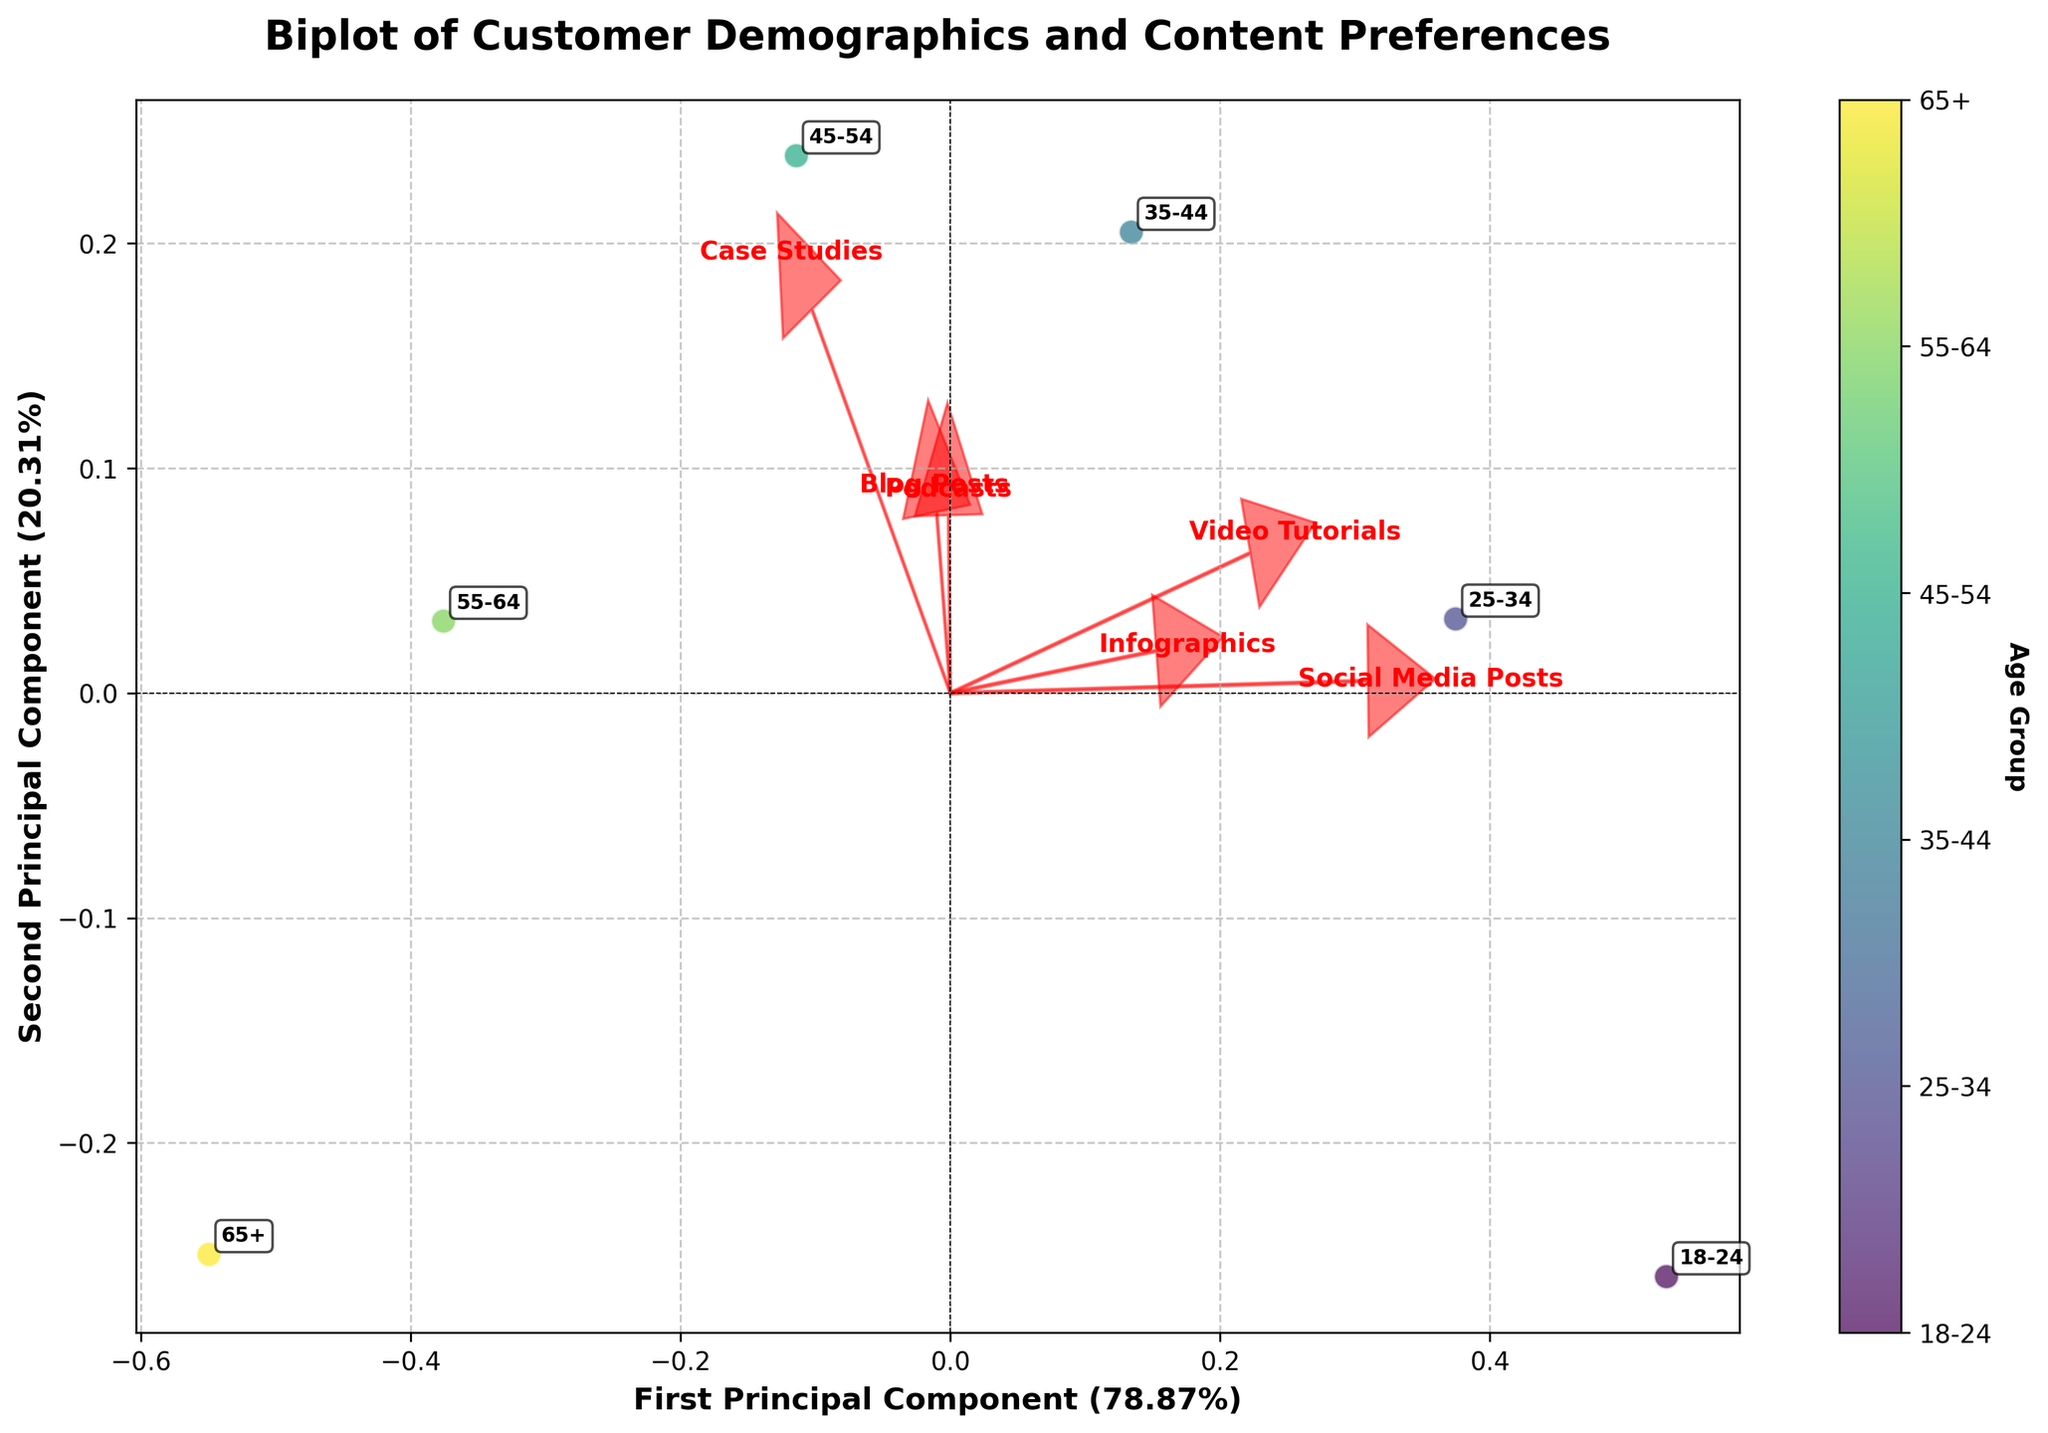How many age groups are represented in the biplot? The biplot shows the data points for each age group. By counting the number of different labels annotated next to the points, we can see there are six distinct age groups.
Answer: Six Which age group shows the highest preference for Video Tutorials? By looking at the length and direction of the arrow representing Video Tutorials and the closeness of the age group points to this arrow, we can infer that the 18-24 age group has the highest preference for Video Tutorials.
Answer: 18-24 What is the approximate variance explained by the first principal component? The x-axis label states "First Principal Component" and shows the variance explained as a percentage in parentheses. By reading this percentage, we find the value.
Answer: Approximately 51% Between 35-44 and 45-54 age groups, which age group shows a higher preference for Podcasts? By observing the biplot, we look for the relative proximity of these two age groups to the arrow representing Podcasts. The 45-54 age group is closer to the Podcasts arrow direction than the 35-44 age group.
Answer: 45-54 Which content type has the least influence on the 65+ age group preferences? By identifying the point corresponding to the 65+ age group on the biplot and assessing its proximity to each content type arrow, we can see that the 65+ age group is furthest from the Video Tutorials arrow, indicating minimal preference.
Answer: Video Tutorials What is the relationship between age and preference for Infographics? Observing the directions and relative positioning of the age groups to the Infographics arrow, older age groups (45-54, 55-64, 65+) show a decreasing trend in preference for Infographics, while younger age groups (18-24, 25-34) have higher preferences.
Answer: Younger age groups prefer Infographics more than older age groups Which content types are most associated with the second principal component? By examining the arrows to see which extend further along the y-axis (Second Principal Component) direction, we note which content types have high values in the second principal component.
Answer: Infographics and Podcasts What can be inferred about Social Media Posts based on the biplot? The vector representing Social Media Posts is prominently directed towards the younger age group points (18-24, 25-34), inferring that younger demographics favor this content type more.
Answer: Younger demographics favor Social Media Posts How does the preference for Case Studies change with age? By examining proximity trends to the arrow representing Case Studies, it appears that older demographics (35-44, 45-54) are closer to the Case Studies direction, indicating higher preferences than younger ones.
Answer: Older demographics prefer Case Studies more 